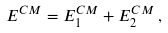<formula> <loc_0><loc_0><loc_500><loc_500>E ^ { C M } = E ^ { C M } _ { 1 } + E ^ { C M } _ { 2 } \, ,</formula> 